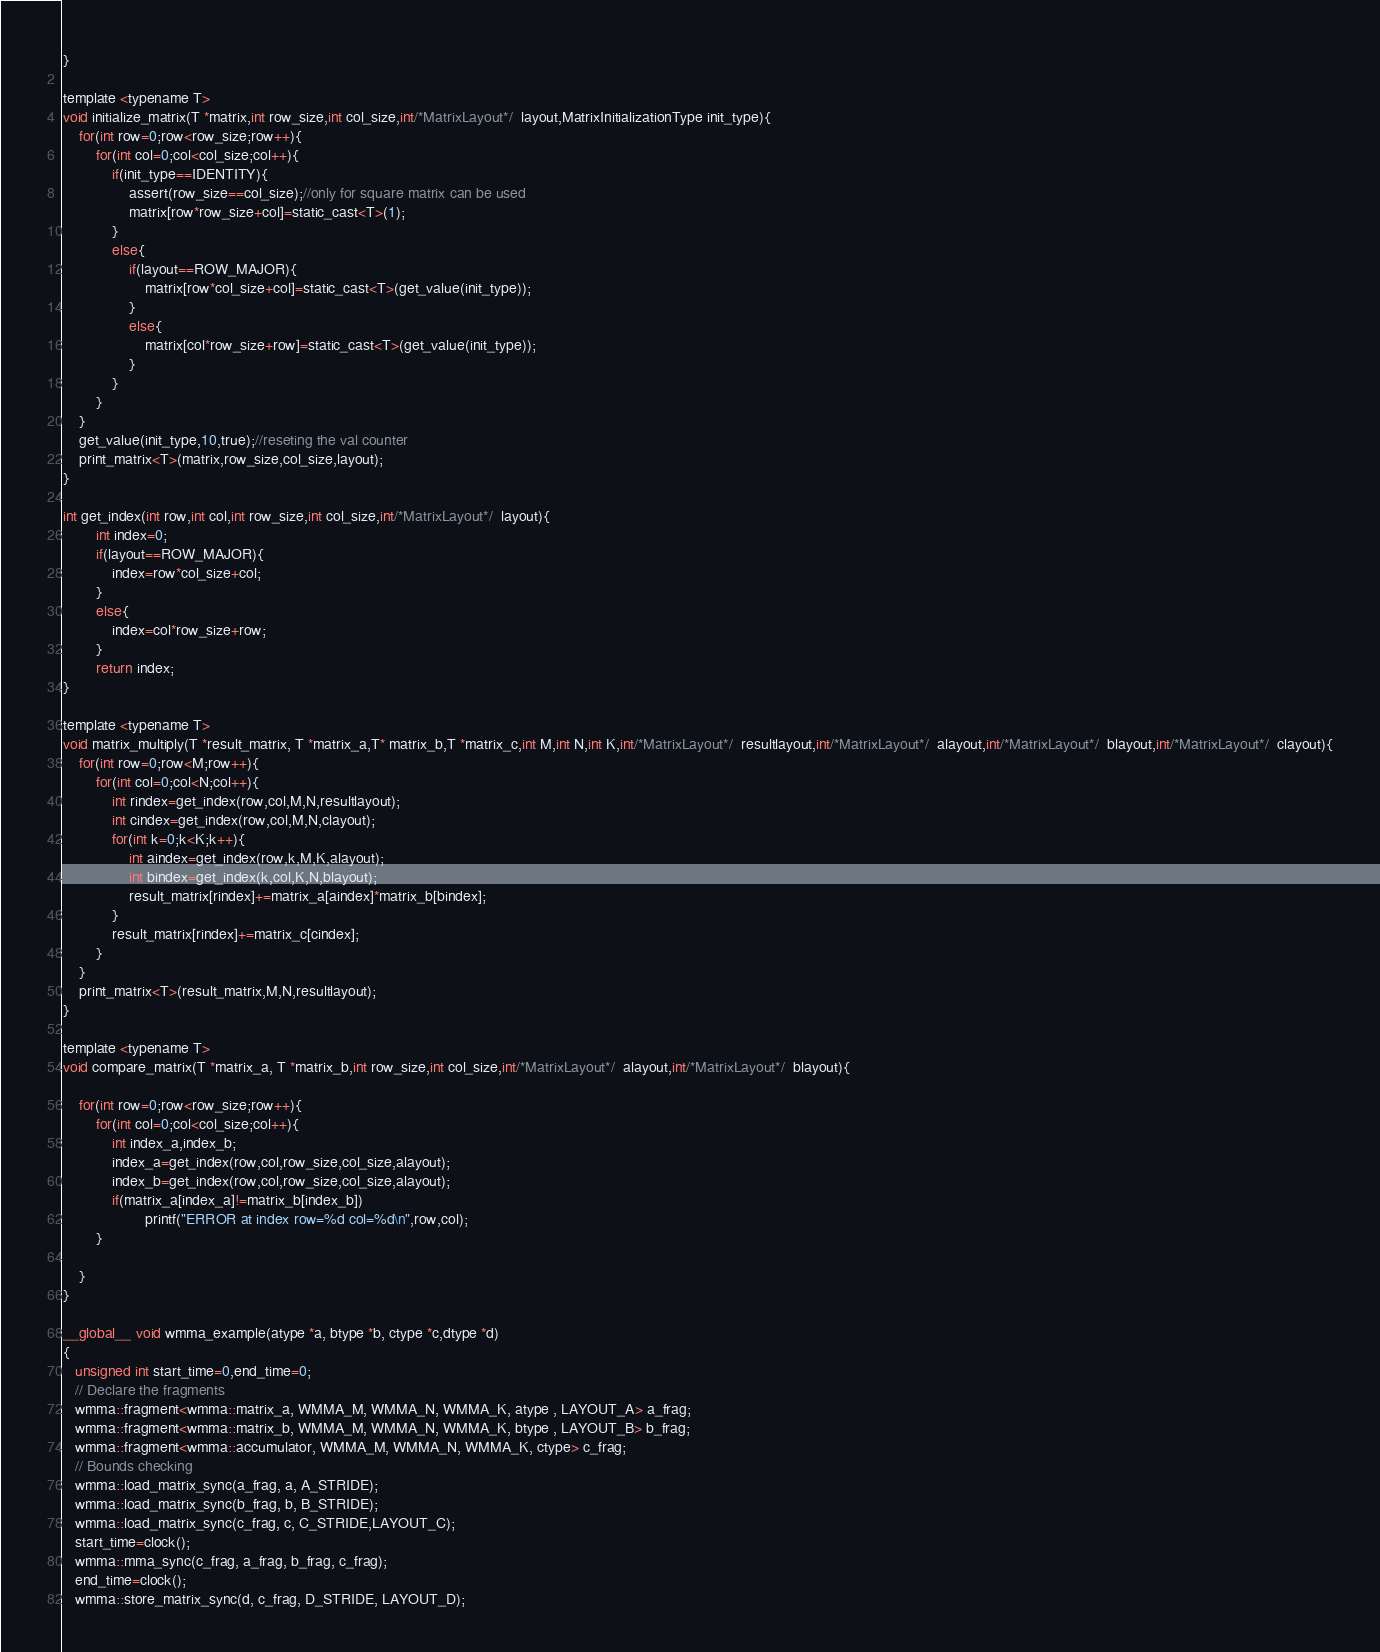Convert code to text. <code><loc_0><loc_0><loc_500><loc_500><_Cuda_>}

template <typename T>
void initialize_matrix(T *matrix,int row_size,int col_size,int/*MatrixLayout*/  layout,MatrixInitializationType init_type){
	for(int row=0;row<row_size;row++){
		for(int col=0;col<col_size;col++){
			if(init_type==IDENTITY){
				assert(row_size==col_size);//only for square matrix can be used
				matrix[row*row_size+col]=static_cast<T>(1);
			}
			else{
				if(layout==ROW_MAJOR){
					matrix[row*col_size+col]=static_cast<T>(get_value(init_type));
				}
				else{
					matrix[col*row_size+row]=static_cast<T>(get_value(init_type));
				}
			}
		}
	}
	get_value(init_type,10,true);//reseting the val counter
  	print_matrix<T>(matrix,row_size,col_size,layout);
}

int get_index(int row,int col,int row_size,int col_size,int/*MatrixLayout*/  layout){
		int index=0;
		if(layout==ROW_MAJOR){
			index=row*col_size+col;		
		}
		else{
			index=col*row_size+row;
		}
		return index;
}

template <typename T>
void matrix_multiply(T *result_matrix, T *matrix_a,T* matrix_b,T *matrix_c,int M,int N,int K,int/*MatrixLayout*/  resultlayout,int/*MatrixLayout*/  alayout,int/*MatrixLayout*/  blayout,int/*MatrixLayout*/  clayout){
	for(int row=0;row<M;row++){
		for(int col=0;col<N;col++){
			int rindex=get_index(row,col,M,N,resultlayout);
			int cindex=get_index(row,col,M,N,clayout);
			for(int k=0;k<K;k++){
				int aindex=get_index(row,k,M,K,alayout);
				int bindex=get_index(k,col,K,N,blayout);
				result_matrix[rindex]+=matrix_a[aindex]*matrix_b[bindex];
			}
			result_matrix[rindex]+=matrix_c[cindex];
		}
	}
   	print_matrix<T>(result_matrix,M,N,resultlayout);
}

template <typename T>	
void compare_matrix(T *matrix_a, T *matrix_b,int row_size,int col_size,int/*MatrixLayout*/  alayout,int/*MatrixLayout*/  blayout){
	
	for(int row=0;row<row_size;row++){
		for(int col=0;col<col_size;col++){
			int index_a,index_b;
			index_a=get_index(row,col,row_size,col_size,alayout);
			index_b=get_index(row,col,row_size,col_size,alayout);
			if(matrix_a[index_a]!=matrix_b[index_b])
					printf("ERROR at index row=%d col=%d\n",row,col);
		}
				
	}
}

__global__ void wmma_example(atype *a, btype *b, ctype *c,dtype *d)
{
   unsigned int start_time=0,end_time=0;
   // Declare the fragments
   wmma::fragment<wmma::matrix_a, WMMA_M, WMMA_N, WMMA_K, atype , LAYOUT_A> a_frag;
   wmma::fragment<wmma::matrix_b, WMMA_M, WMMA_N, WMMA_K, btype , LAYOUT_B> b_frag;
   wmma::fragment<wmma::accumulator, WMMA_M, WMMA_N, WMMA_K, ctype> c_frag;
   // Bounds checking
   wmma::load_matrix_sync(a_frag, a, A_STRIDE);
   wmma::load_matrix_sync(b_frag, b, B_STRIDE);
   wmma::load_matrix_sync(c_frag, c, C_STRIDE,LAYOUT_C);
   start_time=clock();
   wmma::mma_sync(c_frag, a_frag, b_frag, c_frag);
   end_time=clock();
   wmma::store_matrix_sync(d, c_frag, D_STRIDE, LAYOUT_D);</code> 